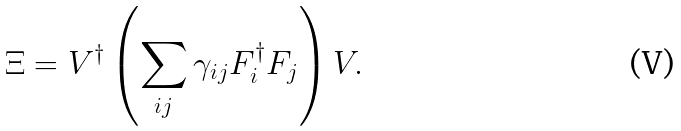<formula> <loc_0><loc_0><loc_500><loc_500>\Xi = V ^ { \dagger } \left ( \sum _ { i j } \gamma _ { i j } F _ { i } ^ { \dagger } F _ { j } \right ) V .</formula> 